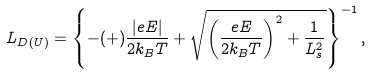<formula> <loc_0><loc_0><loc_500><loc_500>L _ { D ( U ) } = \left \{ - ( + ) \frac { \left | e E \right | } { 2 k _ { B } T } + \sqrt { \left ( \frac { e E } { 2 k _ { B } T } \right ) ^ { 2 } + \frac { 1 } { L _ { s } ^ { 2 } } } \right \} ^ { - 1 } ,</formula> 